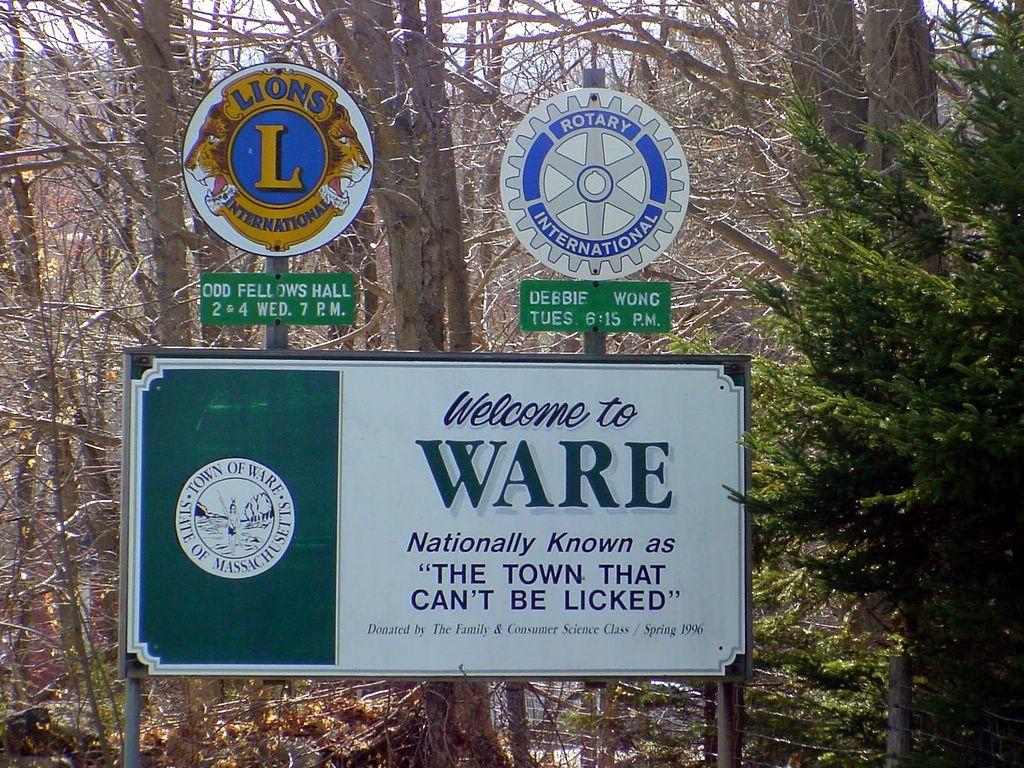What is the town of ware known as?
Your answer should be compact. The town that can't be licked. What town is welcoming us?
Make the answer very short. Ware. 